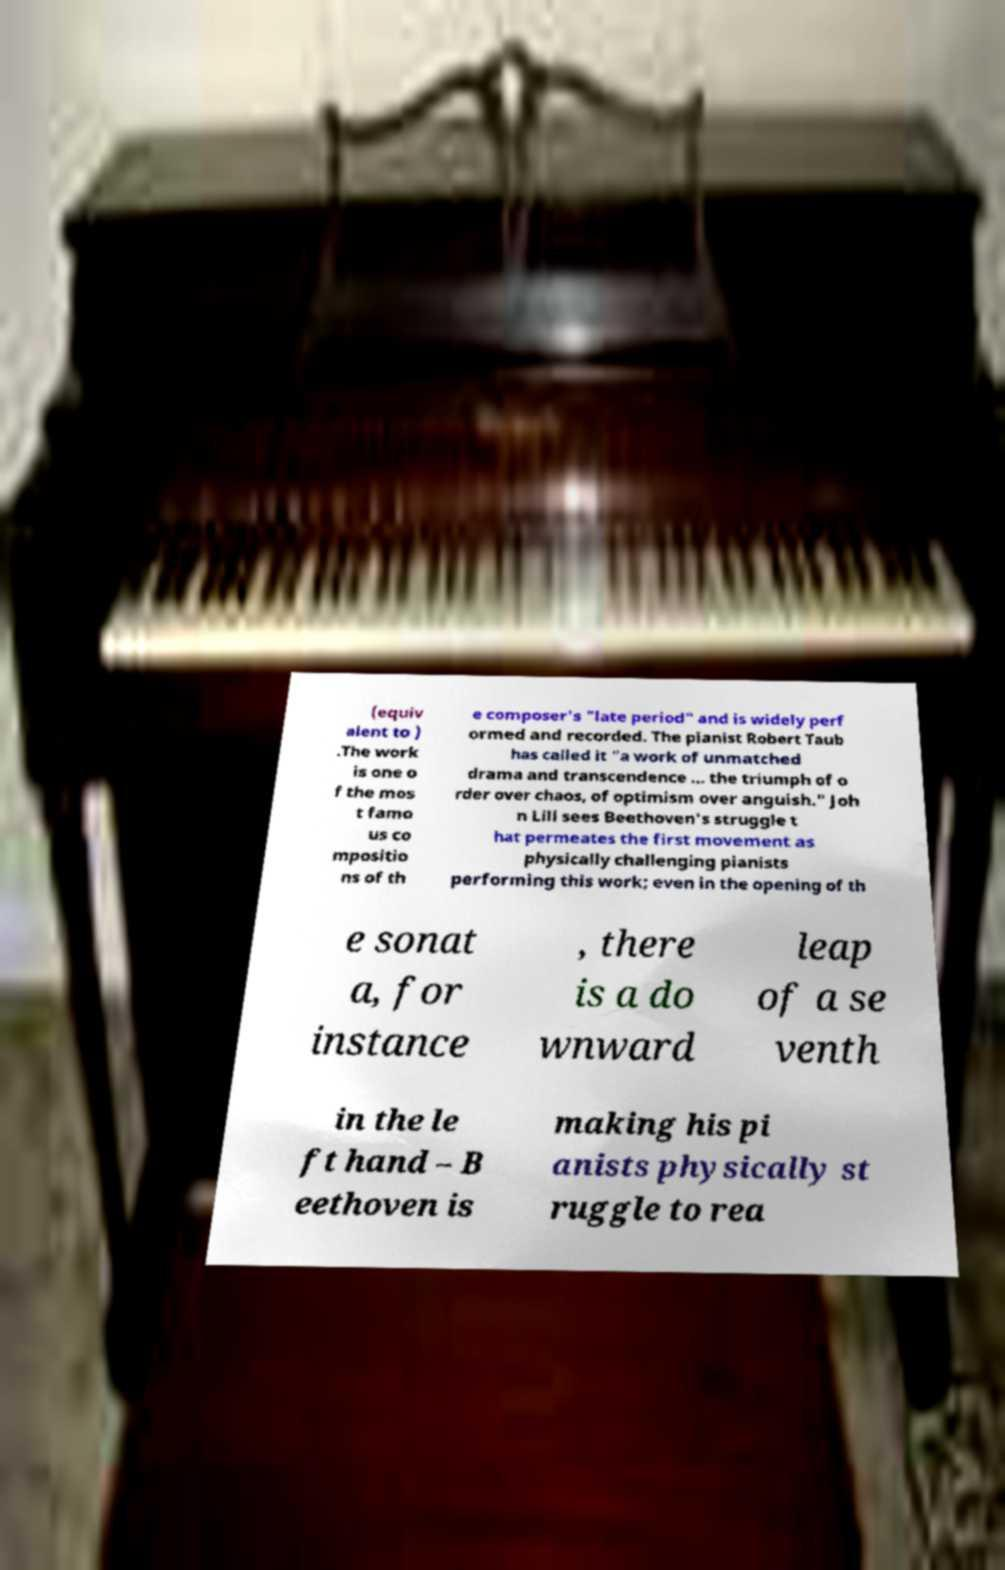Can you read and provide the text displayed in the image?This photo seems to have some interesting text. Can you extract and type it out for me? (equiv alent to ) .The work is one o f the mos t famo us co mpositio ns of th e composer's "late period" and is widely perf ormed and recorded. The pianist Robert Taub has called it "a work of unmatched drama and transcendence ... the triumph of o rder over chaos, of optimism over anguish." Joh n Lill sees Beethoven's struggle t hat permeates the first movement as physically challenging pianists performing this work; even in the opening of th e sonat a, for instance , there is a do wnward leap of a se venth in the le ft hand – B eethoven is making his pi anists physically st ruggle to rea 